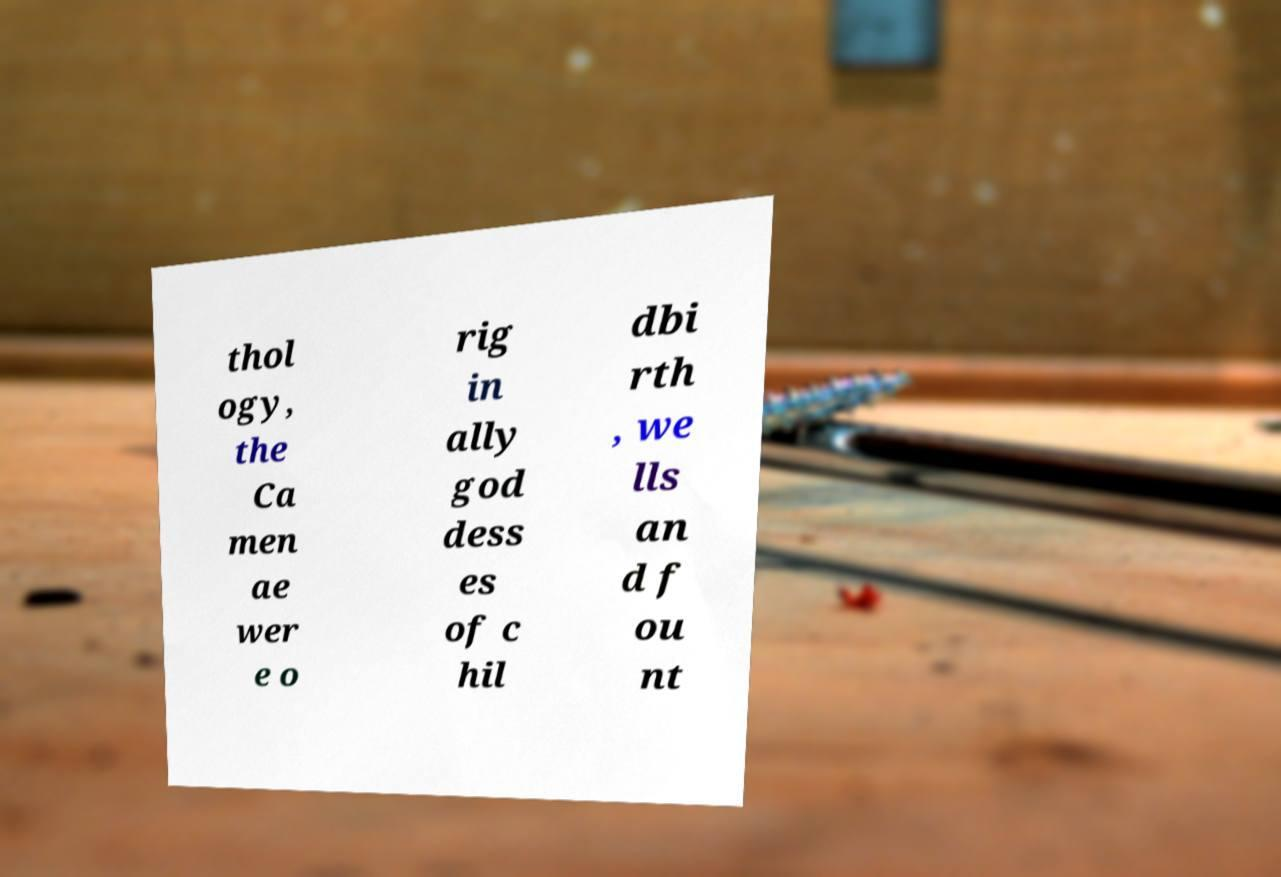Please identify and transcribe the text found in this image. thol ogy, the Ca men ae wer e o rig in ally god dess es of c hil dbi rth , we lls an d f ou nt 